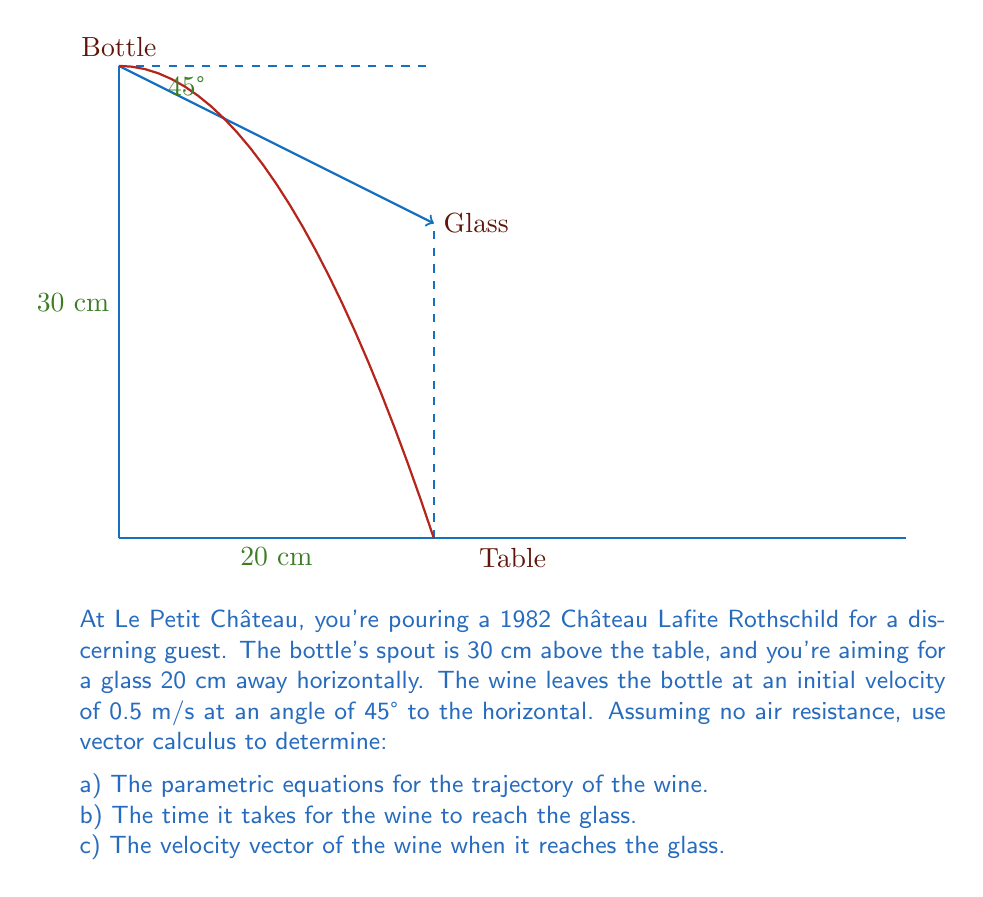Can you answer this question? Let's approach this step-by-step using vector calculus:

1) First, we need to set up our coordinate system. Let's use meters as our unit, with the origin at the base of the bottle on the table.

2) The initial position vector is:
   $$\vec{r_0} = \begin{pmatrix} 0 \\ 0.3 \end{pmatrix}$$

3) The initial velocity vector is:
   $$\vec{v_0} = 0.5 \begin{pmatrix} \cos 45° \\ \sin 45° \end{pmatrix} = \frac{0.5}{\sqrt{2}} \begin{pmatrix} 1 \\ 1 \end{pmatrix}$$

4) The acceleration due to gravity is:
   $$\vec{a} = \begin{pmatrix} 0 \\ -9.8 \end{pmatrix}$$

5) Now, we can write the parametric equations for the trajectory:
   $$\vec{r}(t) = \vec{r_0} + \vec{v_0}t + \frac{1}{2}\vec{a}t^2$$
   
   $$\vec{r}(t) = \begin{pmatrix} 0 \\ 0.3 \end{pmatrix} + \frac{0.5}{\sqrt{2}} \begin{pmatrix} 1 \\ 1 \end{pmatrix}t + \frac{1}{2}\begin{pmatrix} 0 \\ -9.8 \end{pmatrix}t^2$$
   
   $$\vec{r}(t) = \begin{pmatrix} \frac{0.5}{\sqrt{2}}t \\ 0.3 + \frac{0.5}{\sqrt{2}}t - 4.9t^2 \end{pmatrix}$$

   This answers part a).

6) To find when the wine reaches the glass, we need to solve for t when x = 0.2 m:
   $$0.2 = \frac{0.5}{\sqrt{2}}t$$
   $$t = \frac{0.2\sqrt{2}}{0.5} \approx 0.5657 \text{ seconds}$$

   This answers part b).

7) The velocity vector at any time t is given by:
   $$\vec{v}(t) = \vec{v_0} + \vec{a}t$$
   
   $$\vec{v}(t) = \frac{0.5}{\sqrt{2}} \begin{pmatrix} 1 \\ 1 \end{pmatrix} + \begin{pmatrix} 0 \\ -9.8 \end{pmatrix}t$$
   
   At t ≈ 0.5657 seconds:
   
   $$\vec{v}(0.5657) \approx \begin{pmatrix} 0.3536 \\ -5.1992 \end{pmatrix} \text{ m/s}$$

   This answers part c).
Answer: a) $\vec{r}(t) = \begin{pmatrix} \frac{0.5}{\sqrt{2}}t \\ 0.3 + \frac{0.5}{\sqrt{2}}t - 4.9t^2 \end{pmatrix}$
b) t ≈ 0.5657 seconds
c) $\vec{v}(0.5657) \approx \begin{pmatrix} 0.3536 \\ -5.1992 \end{pmatrix}$ m/s 